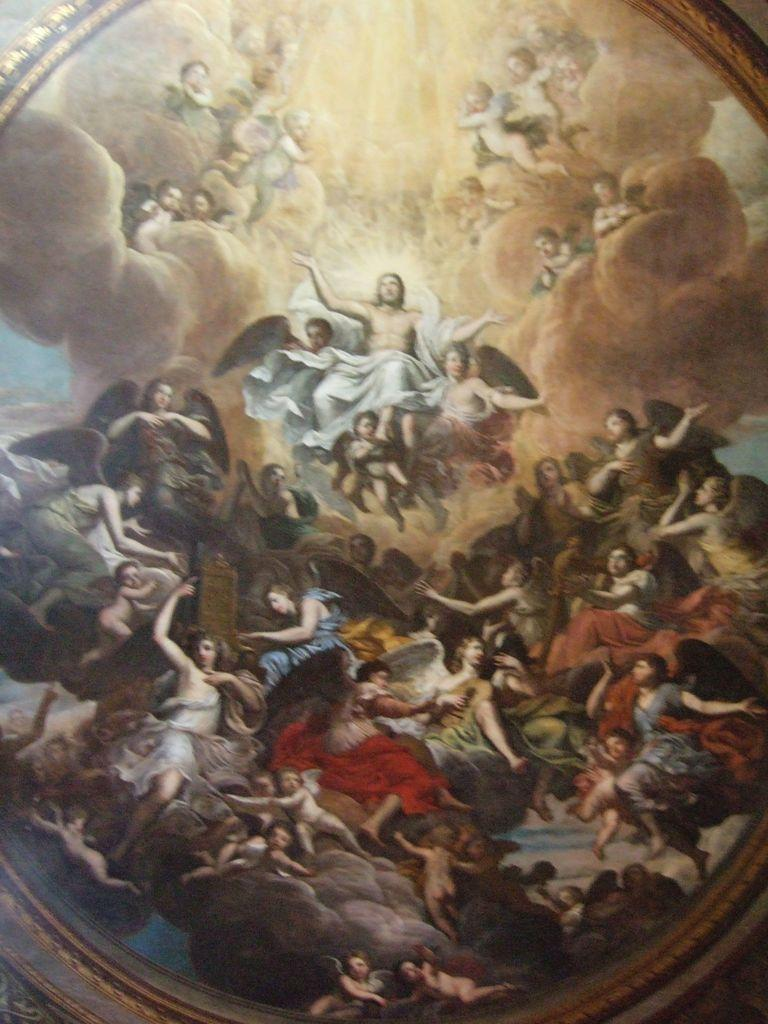What type of artwork is depicted in the image? The image is a painting. Can you describe the subjects in the painting? There are persons in the painting. How is the painting displayed in the image? The painting appears to be framed. What time of day is depicted in the painting? The time of day is not explicitly mentioned or depicted in the painting, so it cannot be determined from the image. 